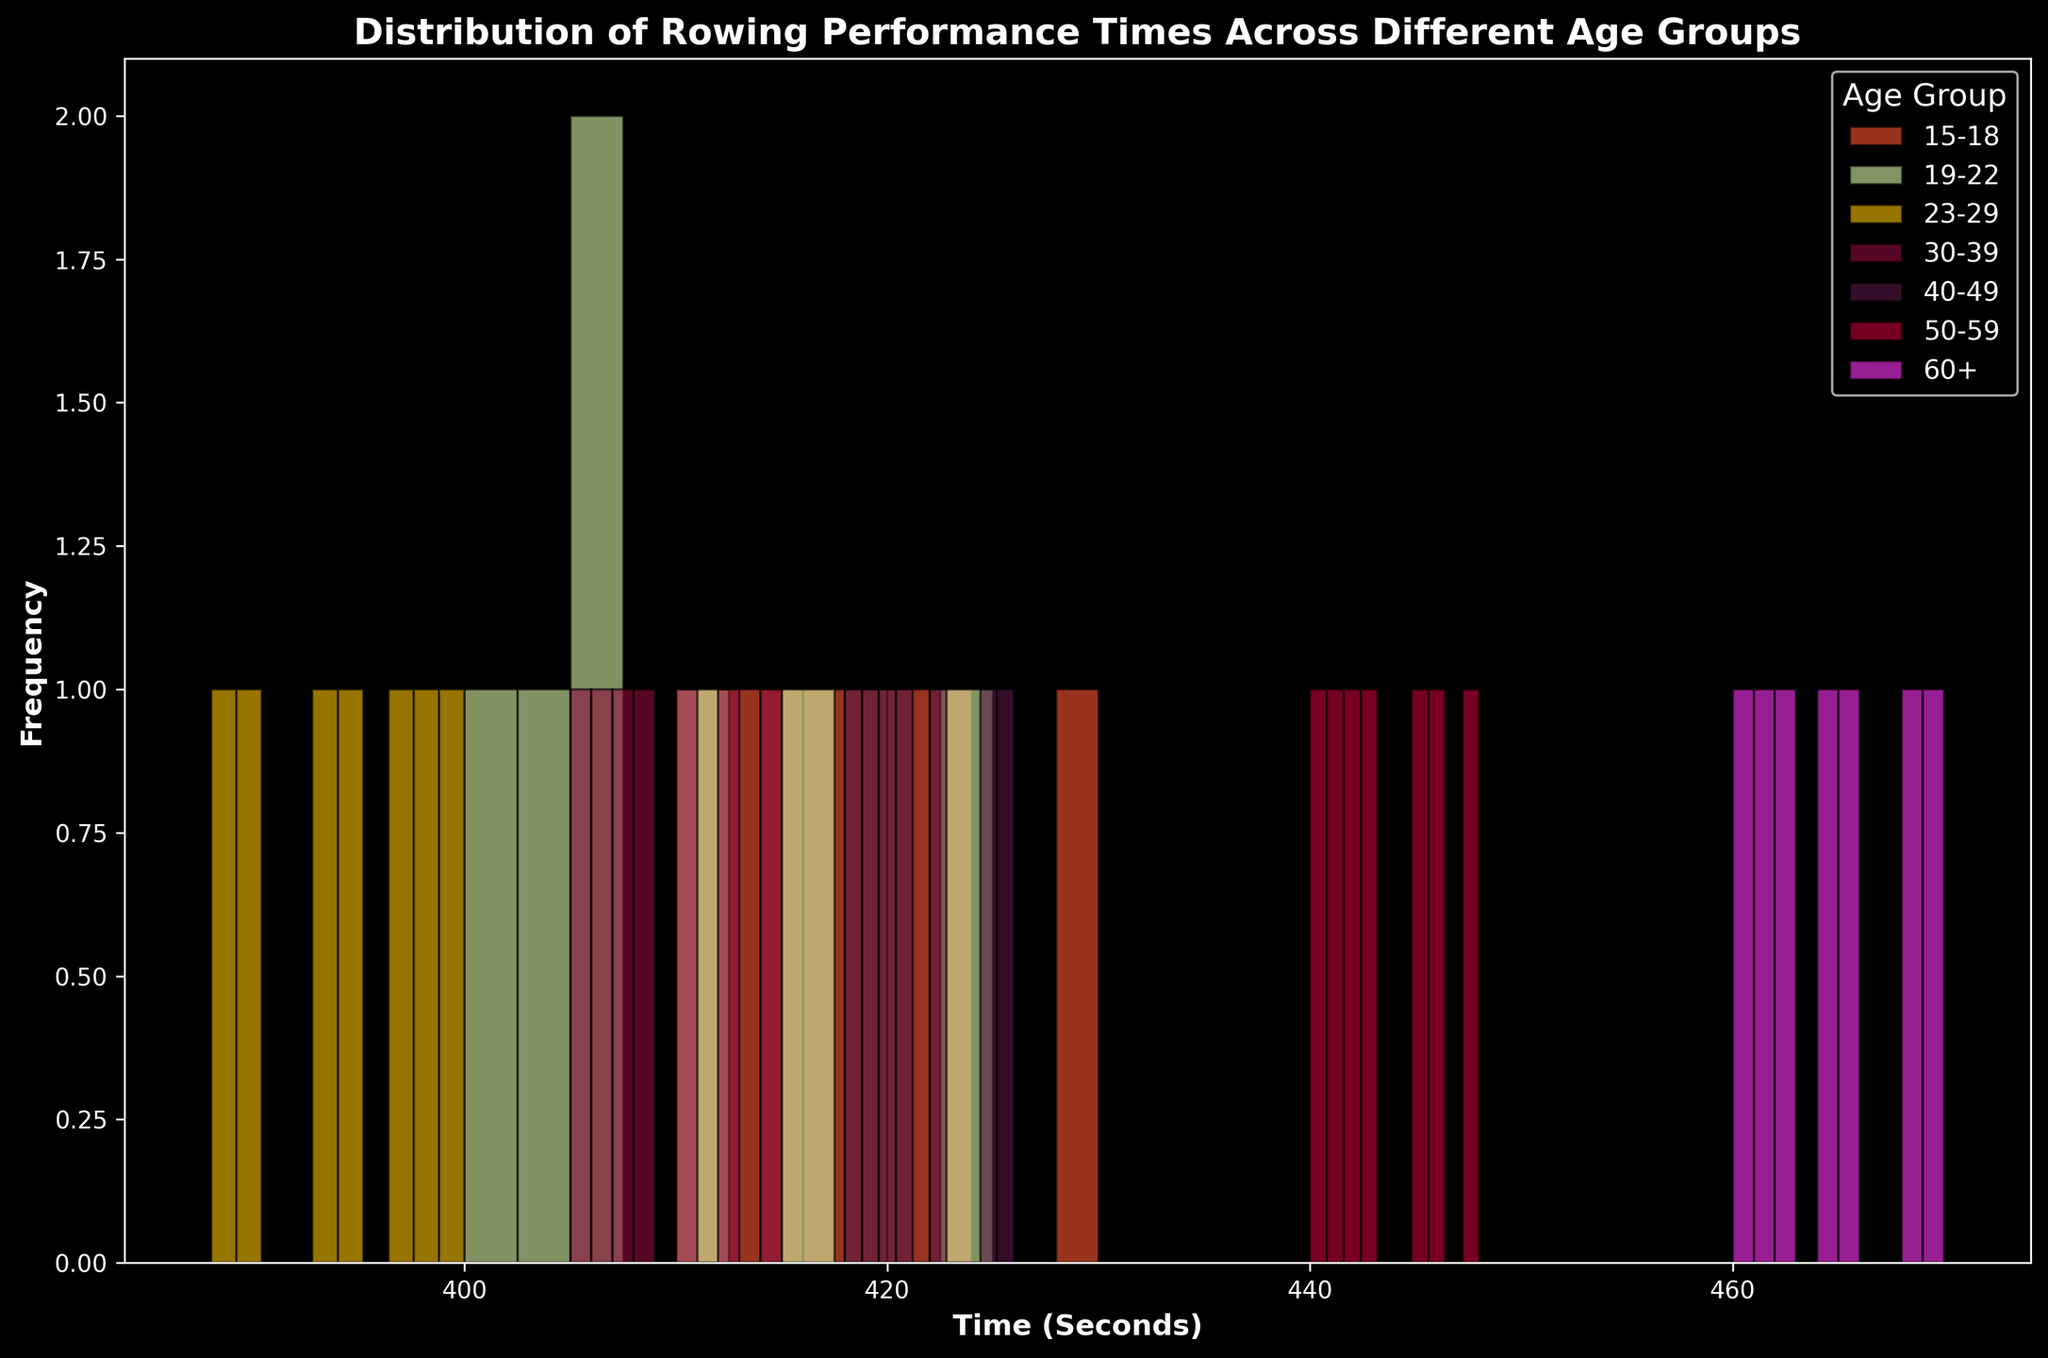What age group has the highest rowing performance times? To identify the age group with the highest rowing performance times, we look for the group with the rightmost histogram bins. The histogram for the 60+ age group is further right (around 460–470 seconds), indicating they have the highest times.
Answer: 60+ Which age group has the most concentrated rowing performance times? To find the most concentrated rowing performance times, we look for the histogram with the narrowest spread of bars. The 23-29 age group has a tightly clustered histogram between 388 and 400 seconds.
Answer: 23-29 Compare the average rowing performance time between the 15-18 and 30-39 age groups. Calculate the average time for each group. For the 15-18 group: (420 + 410 + 415 + 418 + 430 + 422 + 413 + 417)/8 = 418.13 seconds. For the 30-39 group: (405 + 410 + 407 + 408 + 406 + 412 + 415)/7 = 409.00 seconds. Comparing these, the 15-18 age group has a higher average time.
Answer: 15-18: 418.13, 30-39: 409.00 Which age group has the lowest average rowing performance time? When calculating the average for each age group and comparing them, the 23-29 age group has the lowest average, averaging around 393 seconds.
Answer: 23-29 Are there any age groups with overlapping performance times? By observing the histogram, the 15-18 and 19-22 age groups show overlapping performance times as both have times around 410-420 seconds. The histograms for these age groups also overlap significantly.
Answer: Yes, 15-18 and 19-22 What is the range of the rowing performance times for the 50-59 age group? Identify the minimum and maximum values for the 50-59 age group. The times range from 440 seconds (minimum) to 448 seconds (maximum). The range is 448 - 440 = 8 seconds.
Answer: 8 seconds How does the spread of times in the 40-49 age group compare to the 50-59 age group? The spread for each group can be observed from the width of their histograms. The 40-49 group ranges from 418 to 426 seconds, while the 50-59 group ranges from 440 to 448 seconds. Both have a spread of 8 seconds, indicating similar variability.
Answer: Similar spread (both 8 seconds) Among the younger age groups (15-18, 19-22), which has better performance times? Comparing the central tendency (mean or median) and spread of histograms, the 19-22 age group has better (lower) times, primarily clustered around 400-407 seconds, while the 15-18 group clusters around 410-418 seconds.
Answer: 19-22 Which age group shows the highest frequency in a single bin? The highest bar represents the bin with the most frequent times. Observation suggests that the 23-29 age group has a very tall bar around the 390 seconds mark, indicating the highest frequency.
Answer: 23-29 